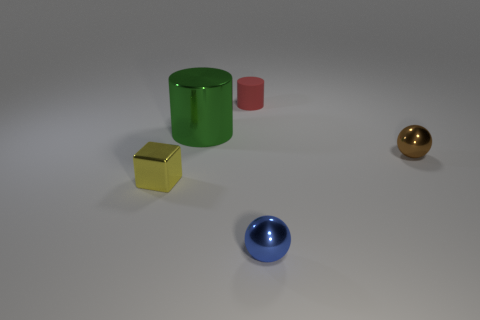Add 1 small brown metallic balls. How many objects exist? 6 Subtract all spheres. How many objects are left? 3 Add 3 small gray metal blocks. How many small gray metal blocks exist? 3 Subtract 1 red cylinders. How many objects are left? 4 Subtract all small cylinders. Subtract all matte cubes. How many objects are left? 4 Add 1 small metal balls. How many small metal balls are left? 3 